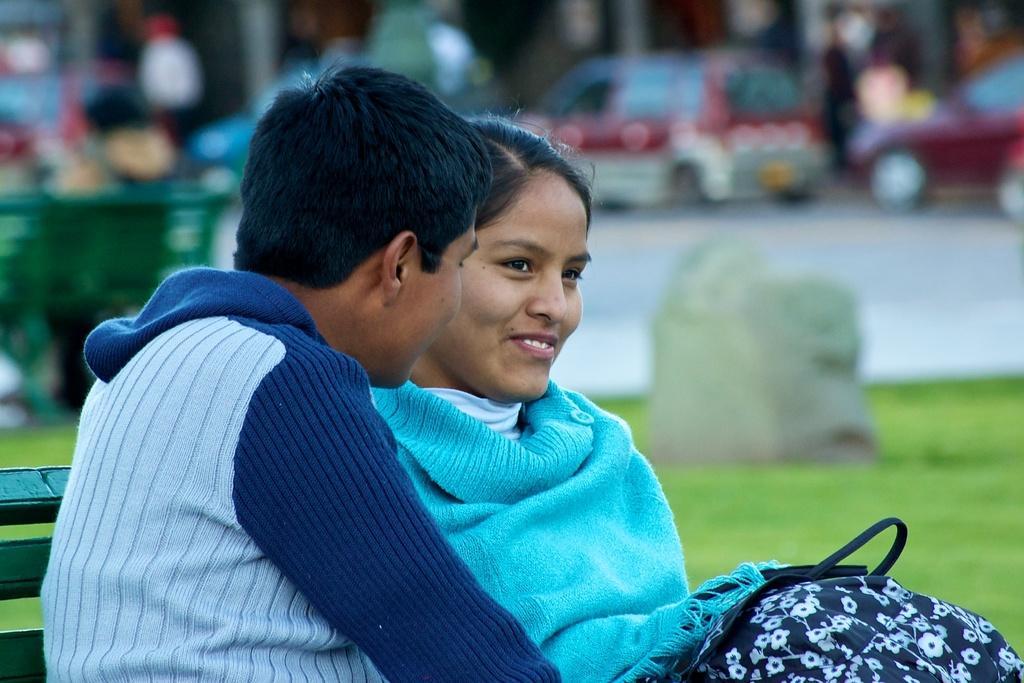Could you give a brief overview of what you see in this image? In this image there is a man and woman sitting on a bench, in the background it is blurred. 